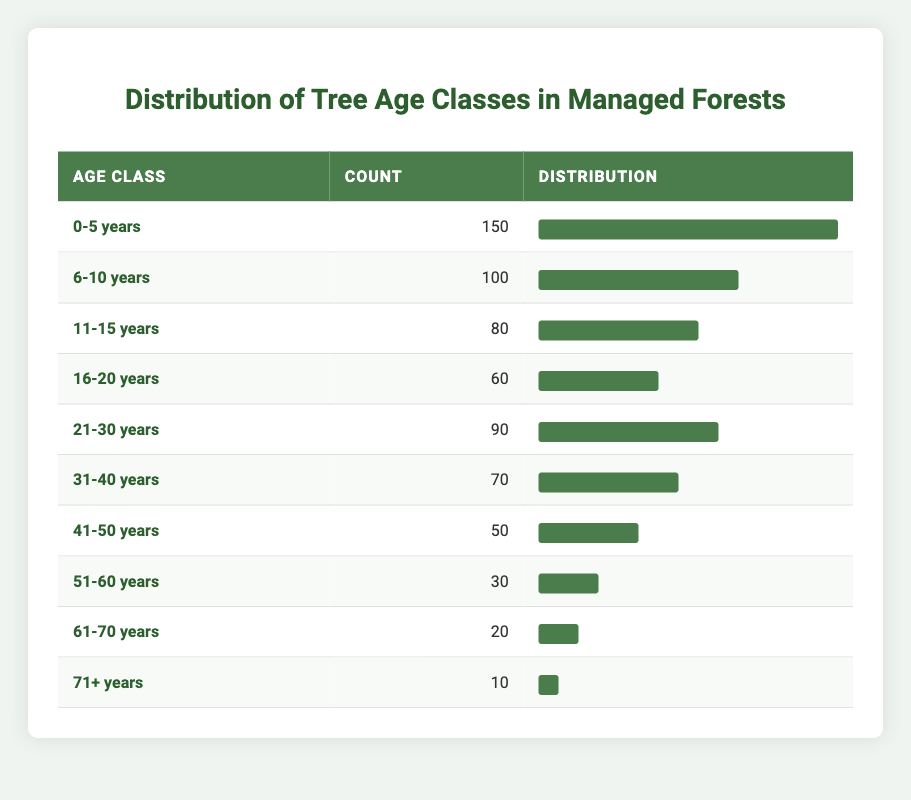What is the age class with the highest count of trees? The table shows the count of trees in different age classes. Upon inspecting the counts, the highest value is 150 in the age class "0-5 years."
Answer: 0-5 years Which age class has the lowest count of trees? The table lists the counts of each age class, and the lowest count is 10, which corresponds to the "71+ years" age class.
Answer: 71+ years What is the total count of trees across all age classes? To find the total count, sum the individual counts from each age class as shown in the table: 150 + 100 + 80 + 60 + 90 + 70 + 50 + 30 + 20 + 10 = 720.
Answer: 720 How many age classes have a count of trees greater than 60? By reviewing the table, the age classes "0-5 years," "6-10 years," "11-15 years," "21-30 years," and "31-40 years" all have counts greater than 60. These add up to 5 age classes.
Answer: 5 What is the average count of trees in the age classes from 41 to 70 years? First, identify the age classes from 41 to 70 years, which are "41-50 years," "51-60 years," and "61-70 years" with counts of 50, 30, and 20 respectively. The sum of these counts is 50 + 30 + 20 = 100, and the average is 100 divided by 3, which equals approximately 33.33.
Answer: 33.33 Is there any age class that has an equal or more than 100 trees? Check the table for counts of 100 or more: "0-5 years" (150) and "6-10 years" (100) both meet this criterion. Thus, there are age classes with counts equal to or greater than 100.
Answer: Yes What is the difference in tree count between the "0-5 years" and "71+ years" age classes? The count for "0-5 years" is 150 and for "71+ years," it is 10. The difference is calculated by subtracting the two counts: 150 - 10 = 140.
Answer: 140 How does the count of trees in the age class "31-40 years" compare to the total number of trees in the age class "16-20 years"? The count in "31-40 years" is 70, while in "16-20 years," it is 60. Therefore, "31-40 years" has more trees: 70 > 60.
Answer: 70 > 60 Are there more trees in the age classes below 30 years or above 30 years? The sum of trees below 30 years includes 150 (0-5 years) + 100 (6-10 years) + 80 (11-15 years) + 60 (16-20 years) + 90 (21-30 years) = 480. In contrast, the sum of trees above 30 years includes 70 (31-40 years) + 50 (41-50 years) + 30 (51-60 years) + 20 (61-70 years) + 10 (71+ years) = 180. Comparing totals: 480 > 180 shows there are more trees below 30 years.
Answer: Below 30 years 